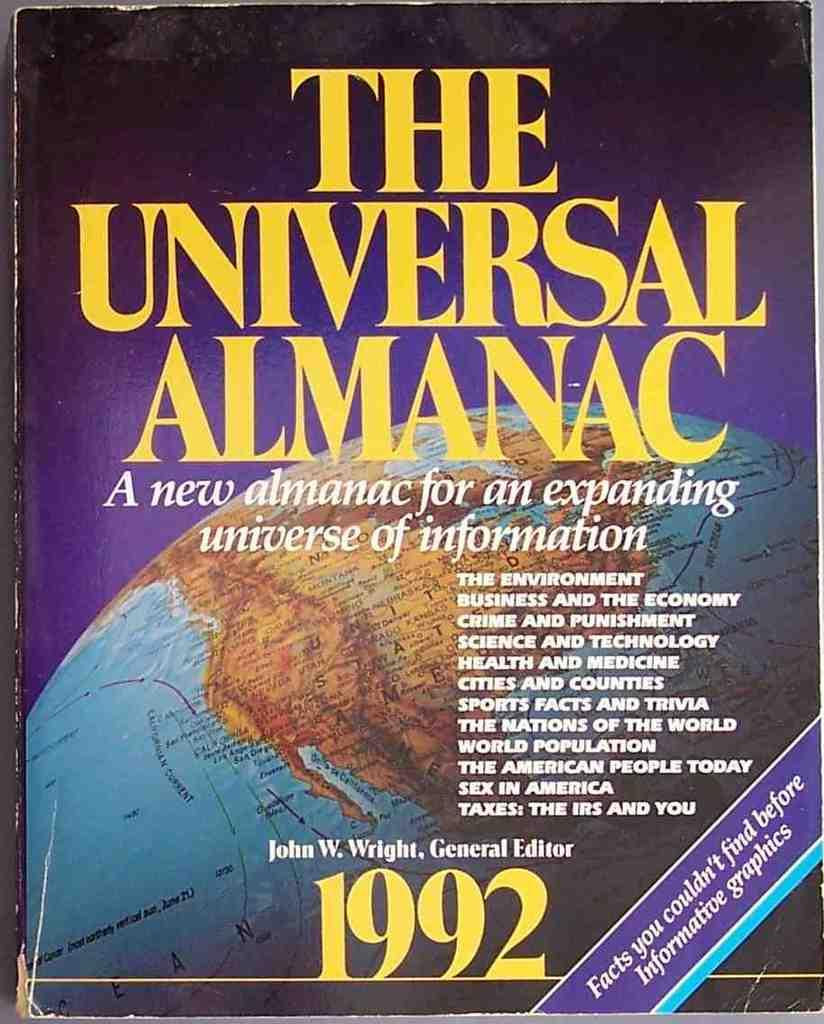What is the main subject of the image? The main subject of the image is a book cover. What can be seen on the book cover? There is text and numbers on the book cover. What type of thread is used to hold the vase on the book cover? There is no vase or thread present on the book cover; it only features text and numbers. 